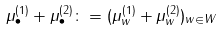Convert formula to latex. <formula><loc_0><loc_0><loc_500><loc_500>\mu _ { \bullet } ^ { ( 1 ) } + \mu _ { \bullet } ^ { ( 2 ) } \colon = ( \mu _ { w } ^ { ( 1 ) } + \mu _ { w } ^ { ( 2 ) } ) _ { w \in W }</formula> 